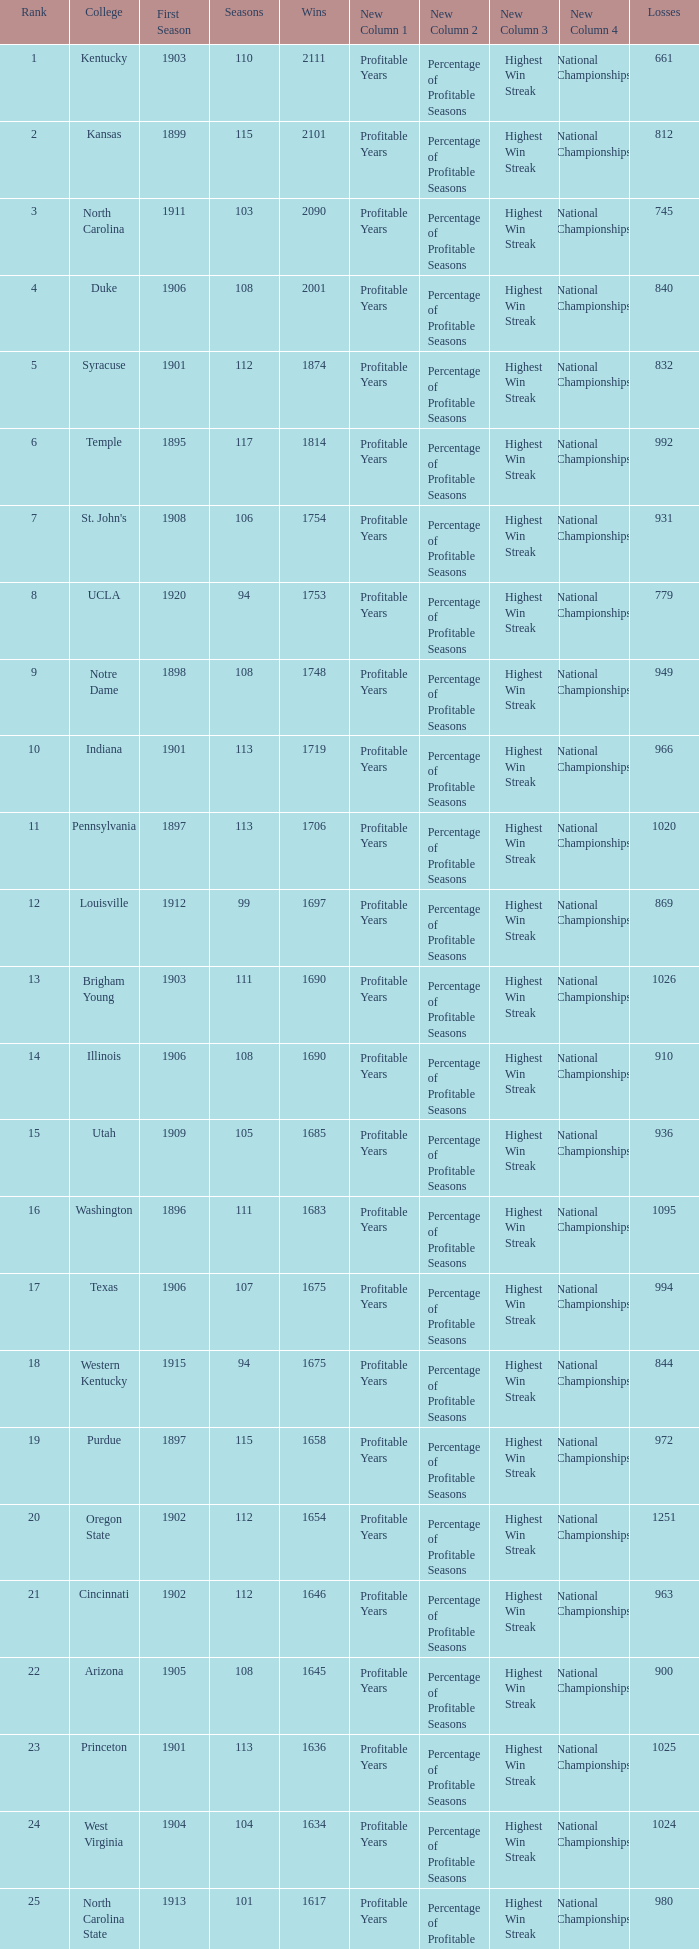What is the total number of rank with losses less than 992, North Carolina State College and a season greater than 101? 0.0. 